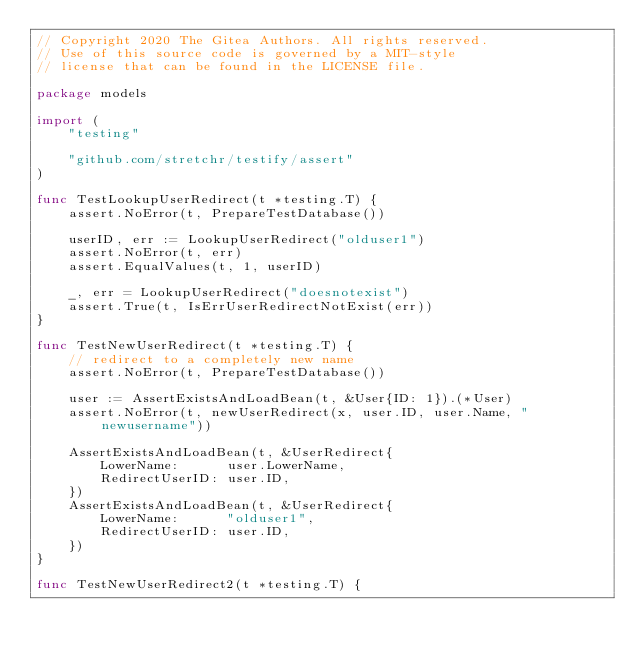<code> <loc_0><loc_0><loc_500><loc_500><_Go_>// Copyright 2020 The Gitea Authors. All rights reserved.
// Use of this source code is governed by a MIT-style
// license that can be found in the LICENSE file.

package models

import (
	"testing"

	"github.com/stretchr/testify/assert"
)

func TestLookupUserRedirect(t *testing.T) {
	assert.NoError(t, PrepareTestDatabase())

	userID, err := LookupUserRedirect("olduser1")
	assert.NoError(t, err)
	assert.EqualValues(t, 1, userID)

	_, err = LookupUserRedirect("doesnotexist")
	assert.True(t, IsErrUserRedirectNotExist(err))
}

func TestNewUserRedirect(t *testing.T) {
	// redirect to a completely new name
	assert.NoError(t, PrepareTestDatabase())

	user := AssertExistsAndLoadBean(t, &User{ID: 1}).(*User)
	assert.NoError(t, newUserRedirect(x, user.ID, user.Name, "newusername"))

	AssertExistsAndLoadBean(t, &UserRedirect{
		LowerName:      user.LowerName,
		RedirectUserID: user.ID,
	})
	AssertExistsAndLoadBean(t, &UserRedirect{
		LowerName:      "olduser1",
		RedirectUserID: user.ID,
	})
}

func TestNewUserRedirect2(t *testing.T) {</code> 